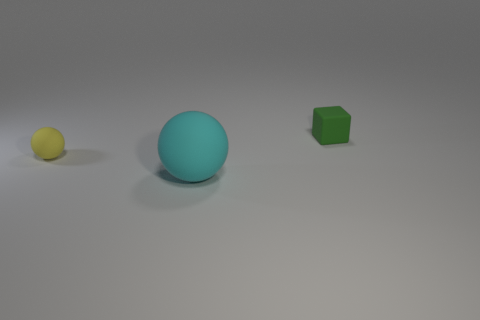Add 3 cyan rubber spheres. How many objects exist? 6 Subtract all cubes. How many objects are left? 2 Subtract all red spheres. Subtract all gray cubes. How many spheres are left? 2 Subtract all small blue shiny cubes. Subtract all small matte cubes. How many objects are left? 2 Add 2 cyan rubber spheres. How many cyan rubber spheres are left? 3 Add 1 brown matte blocks. How many brown matte blocks exist? 1 Subtract 0 purple balls. How many objects are left? 3 